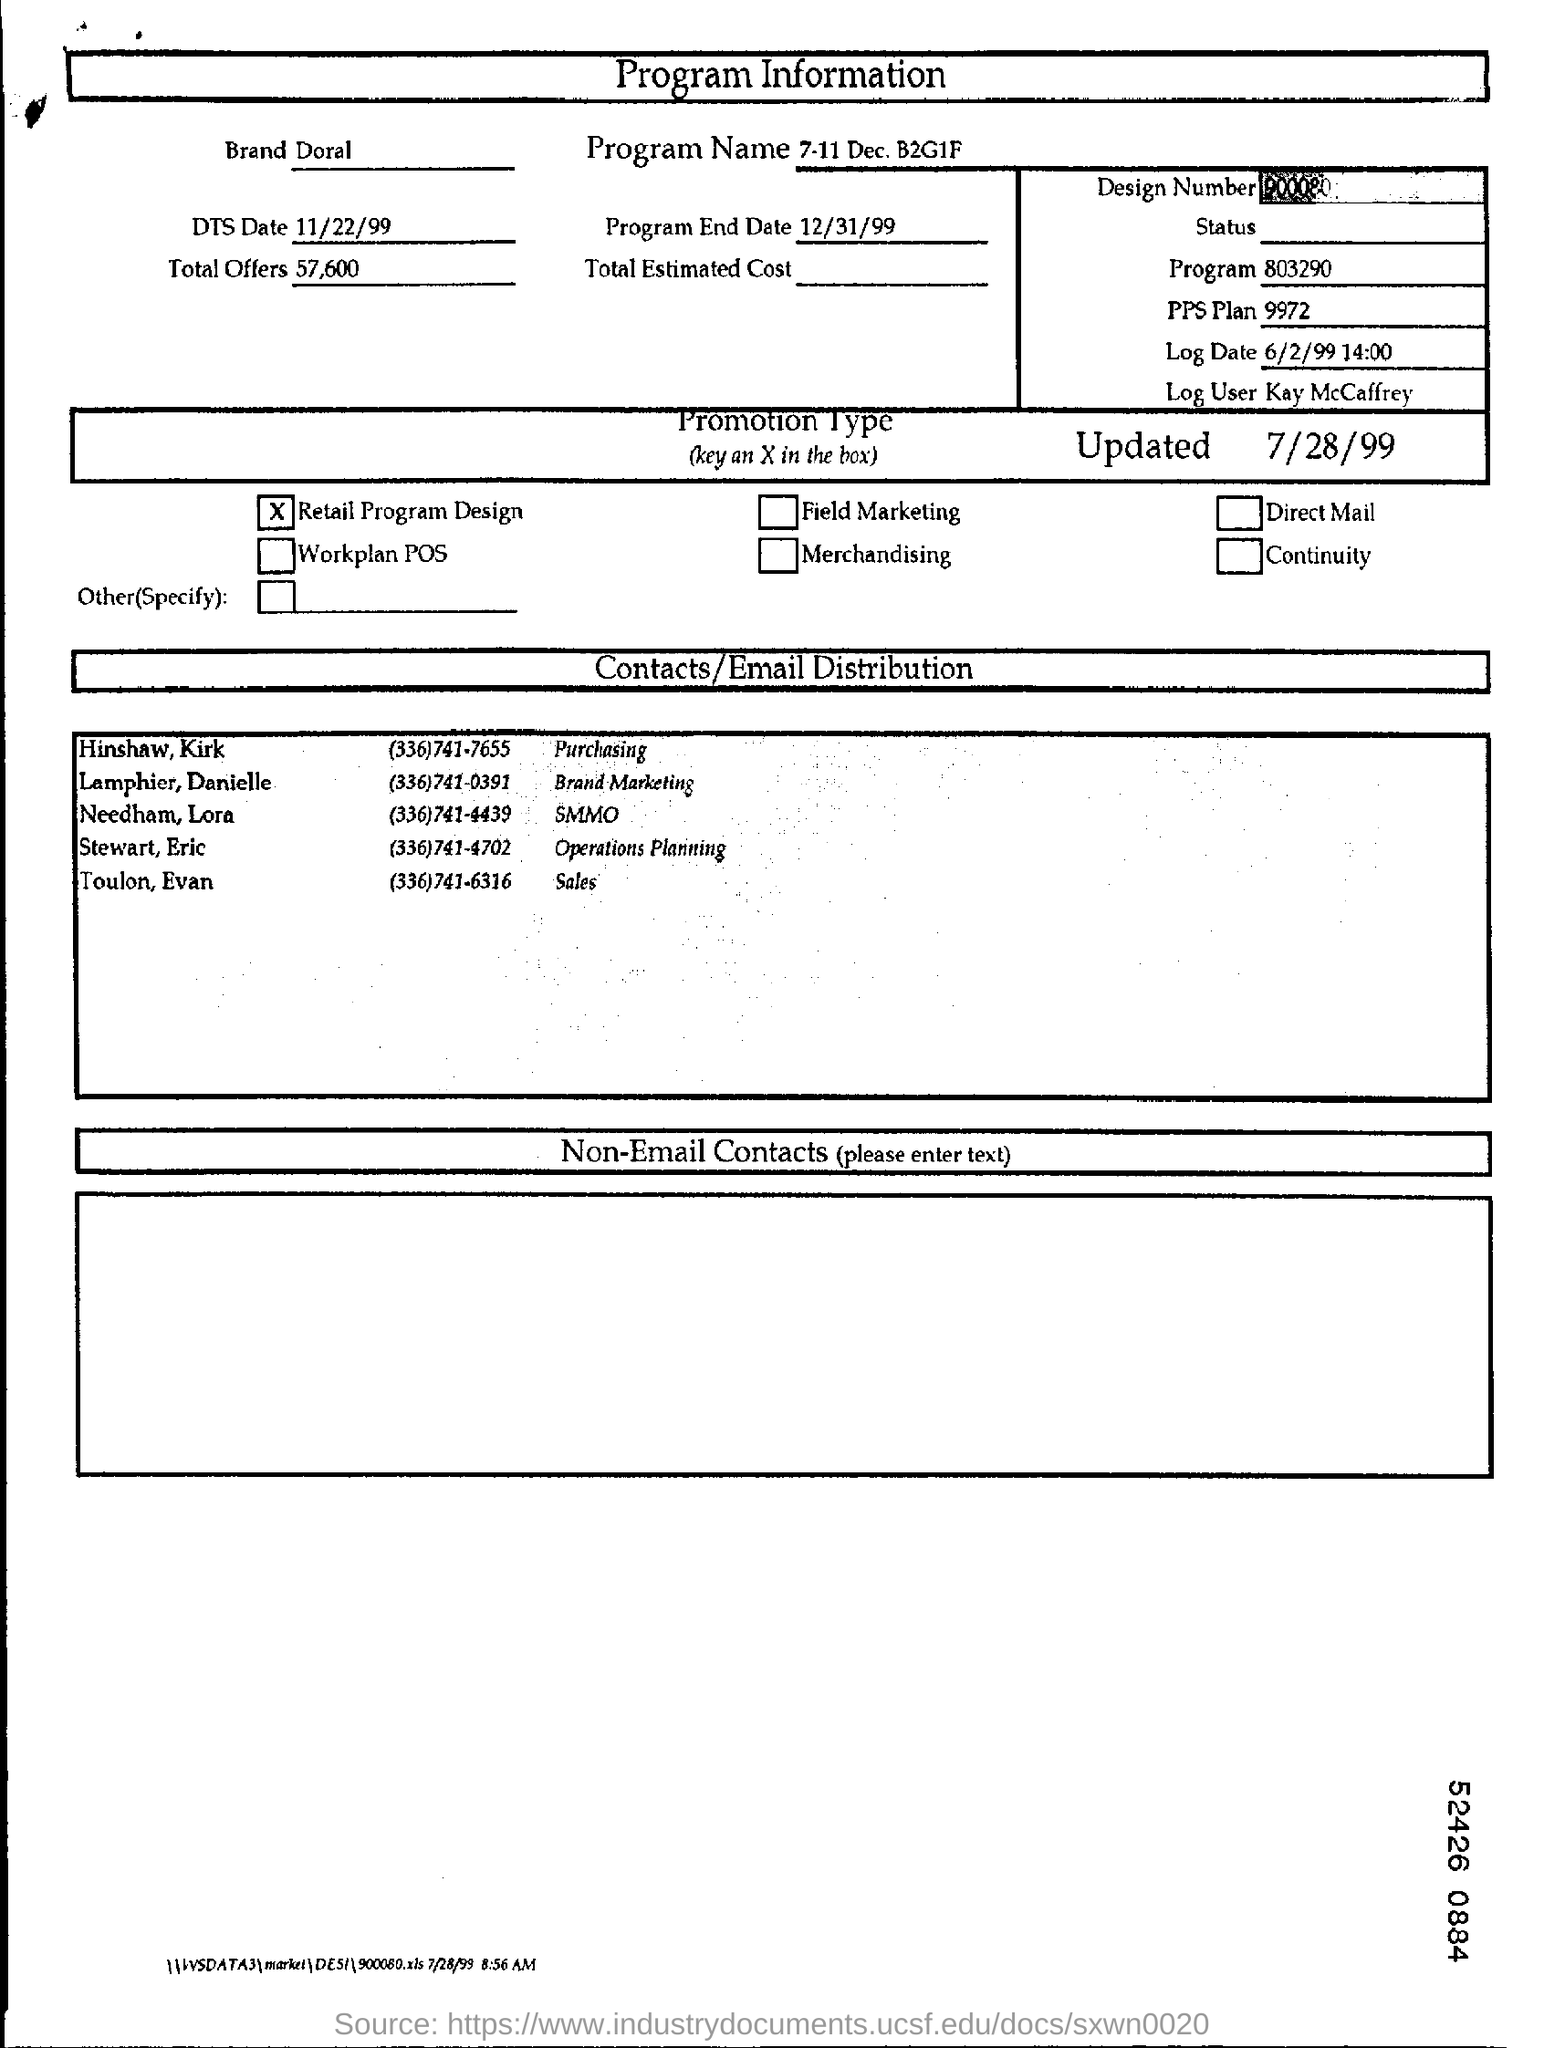Highlight a few significant elements in this photo. There are a total of 57,600 offers. The date is November 22, 1999. The log user is Kay McCaffrey. Please provide the name of the program, as it is currently December 7th and the promotion is Buy One Get One Free on items marked with a green sticker. The type of promotion is a retail program design. 